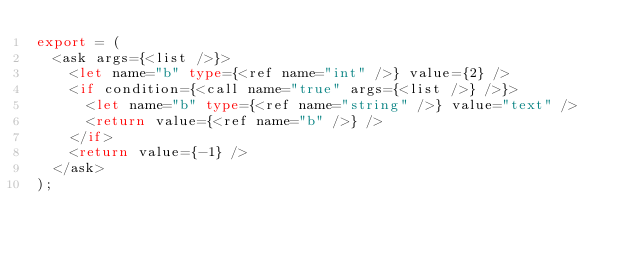<code> <loc_0><loc_0><loc_500><loc_500><_TypeScript_>export = (
  <ask args={<list />}>
    <let name="b" type={<ref name="int" />} value={2} />
    <if condition={<call name="true" args={<list />} />}>
      <let name="b" type={<ref name="string" />} value="text" />
      <return value={<ref name="b" />} />
    </if>
    <return value={-1} />
  </ask>
);
</code> 